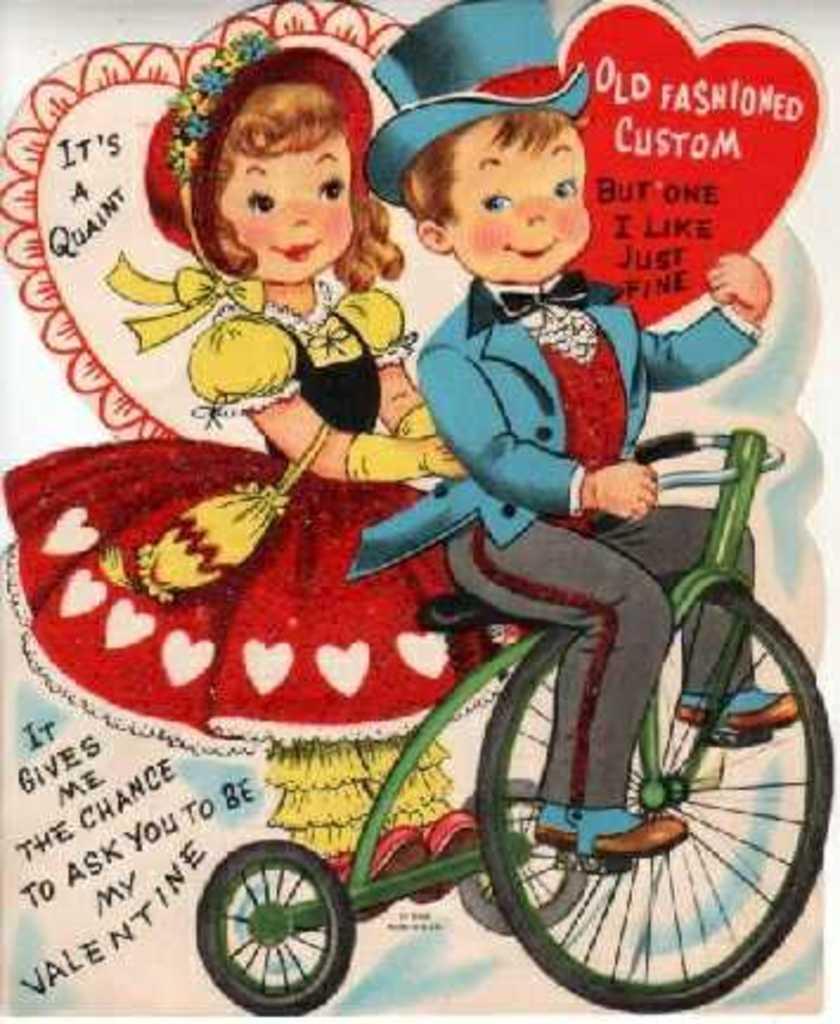How would you summarize this image in a sentence or two? In this image we can see the poster of the boy holding the text card and also riding the bicycle with a girl. We can also see the text. 